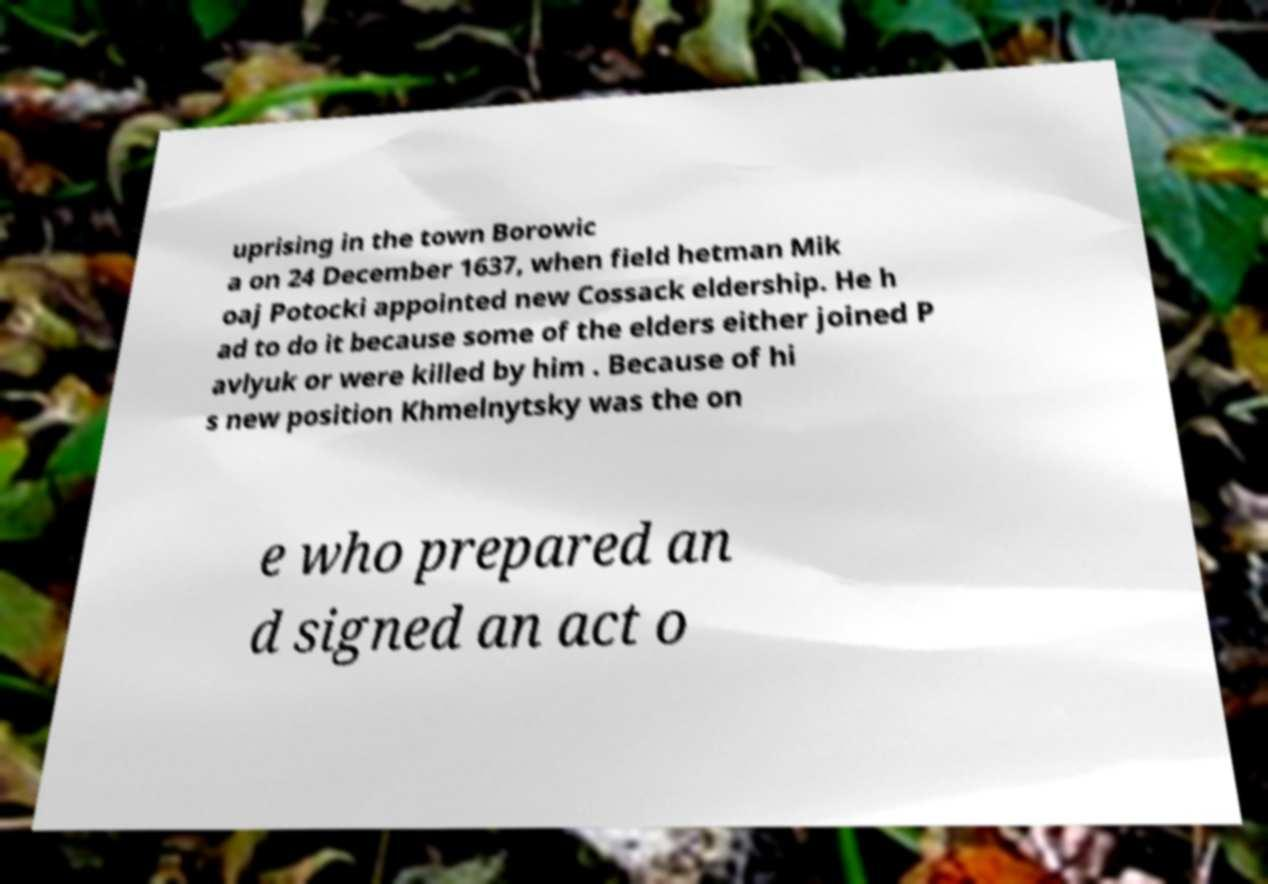Can you accurately transcribe the text from the provided image for me? uprising in the town Borowic a on 24 December 1637, when field hetman Mik oaj Potocki appointed new Cossack eldership. He h ad to do it because some of the elders either joined P avlyuk or were killed by him . Because of hi s new position Khmelnytsky was the on e who prepared an d signed an act o 